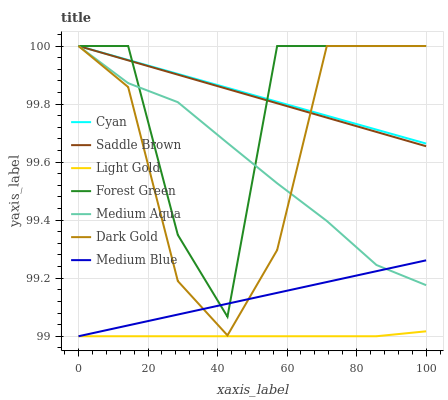Does Light Gold have the minimum area under the curve?
Answer yes or no. Yes. Does Cyan have the maximum area under the curve?
Answer yes or no. Yes. Does Medium Blue have the minimum area under the curve?
Answer yes or no. No. Does Medium Blue have the maximum area under the curve?
Answer yes or no. No. Is Cyan the smoothest?
Answer yes or no. Yes. Is Forest Green the roughest?
Answer yes or no. Yes. Is Medium Blue the smoothest?
Answer yes or no. No. Is Medium Blue the roughest?
Answer yes or no. No. Does Medium Blue have the lowest value?
Answer yes or no. Yes. Does Forest Green have the lowest value?
Answer yes or no. No. Does Saddle Brown have the highest value?
Answer yes or no. Yes. Does Medium Blue have the highest value?
Answer yes or no. No. Is Light Gold less than Medium Aqua?
Answer yes or no. Yes. Is Dark Gold greater than Light Gold?
Answer yes or no. Yes. Does Dark Gold intersect Saddle Brown?
Answer yes or no. Yes. Is Dark Gold less than Saddle Brown?
Answer yes or no. No. Is Dark Gold greater than Saddle Brown?
Answer yes or no. No. Does Light Gold intersect Medium Aqua?
Answer yes or no. No. 